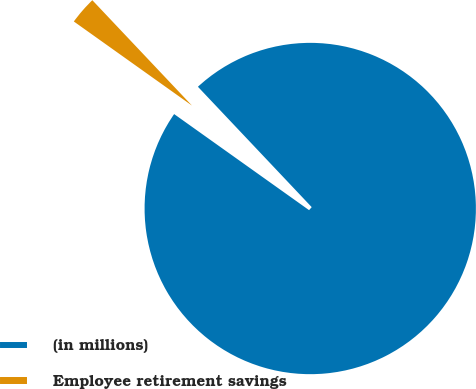Convert chart to OTSL. <chart><loc_0><loc_0><loc_500><loc_500><pie_chart><fcel>(in millions)<fcel>Employee retirement savings<nl><fcel>96.9%<fcel>3.1%<nl></chart> 